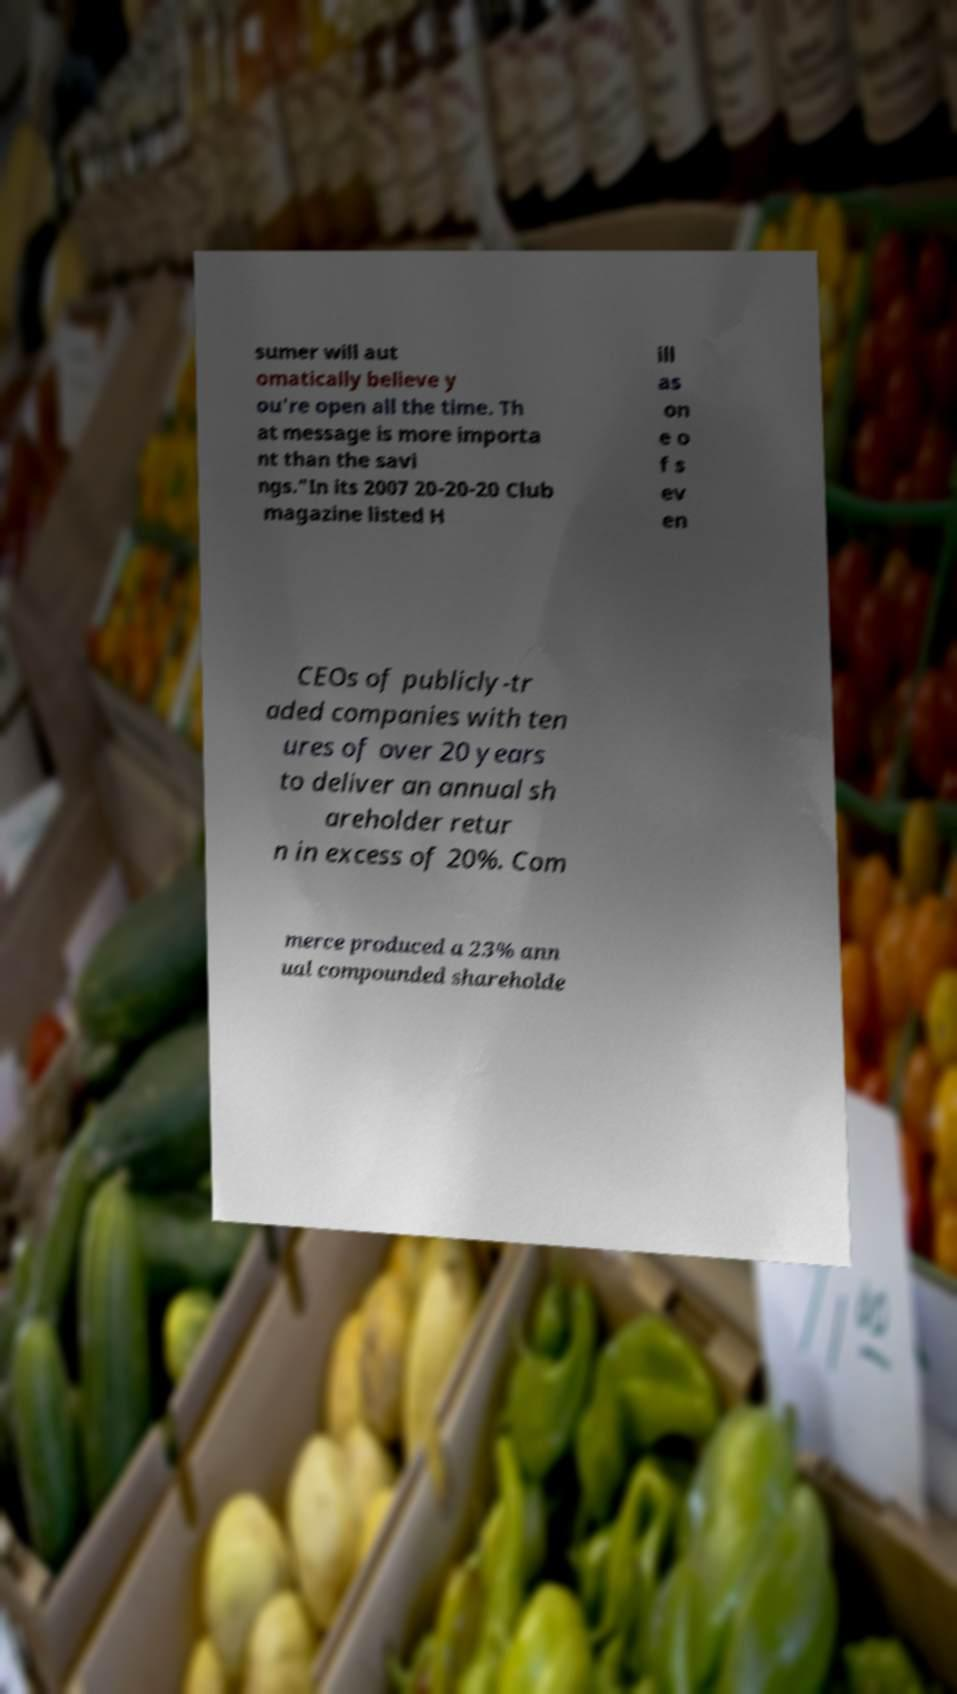What messages or text are displayed in this image? I need them in a readable, typed format. sumer will aut omatically believe y ou're open all the time. Th at message is more importa nt than the savi ngs."In its 2007 20-20-20 Club magazine listed H ill as on e o f s ev en CEOs of publicly-tr aded companies with ten ures of over 20 years to deliver an annual sh areholder retur n in excess of 20%. Com merce produced a 23% ann ual compounded shareholde 